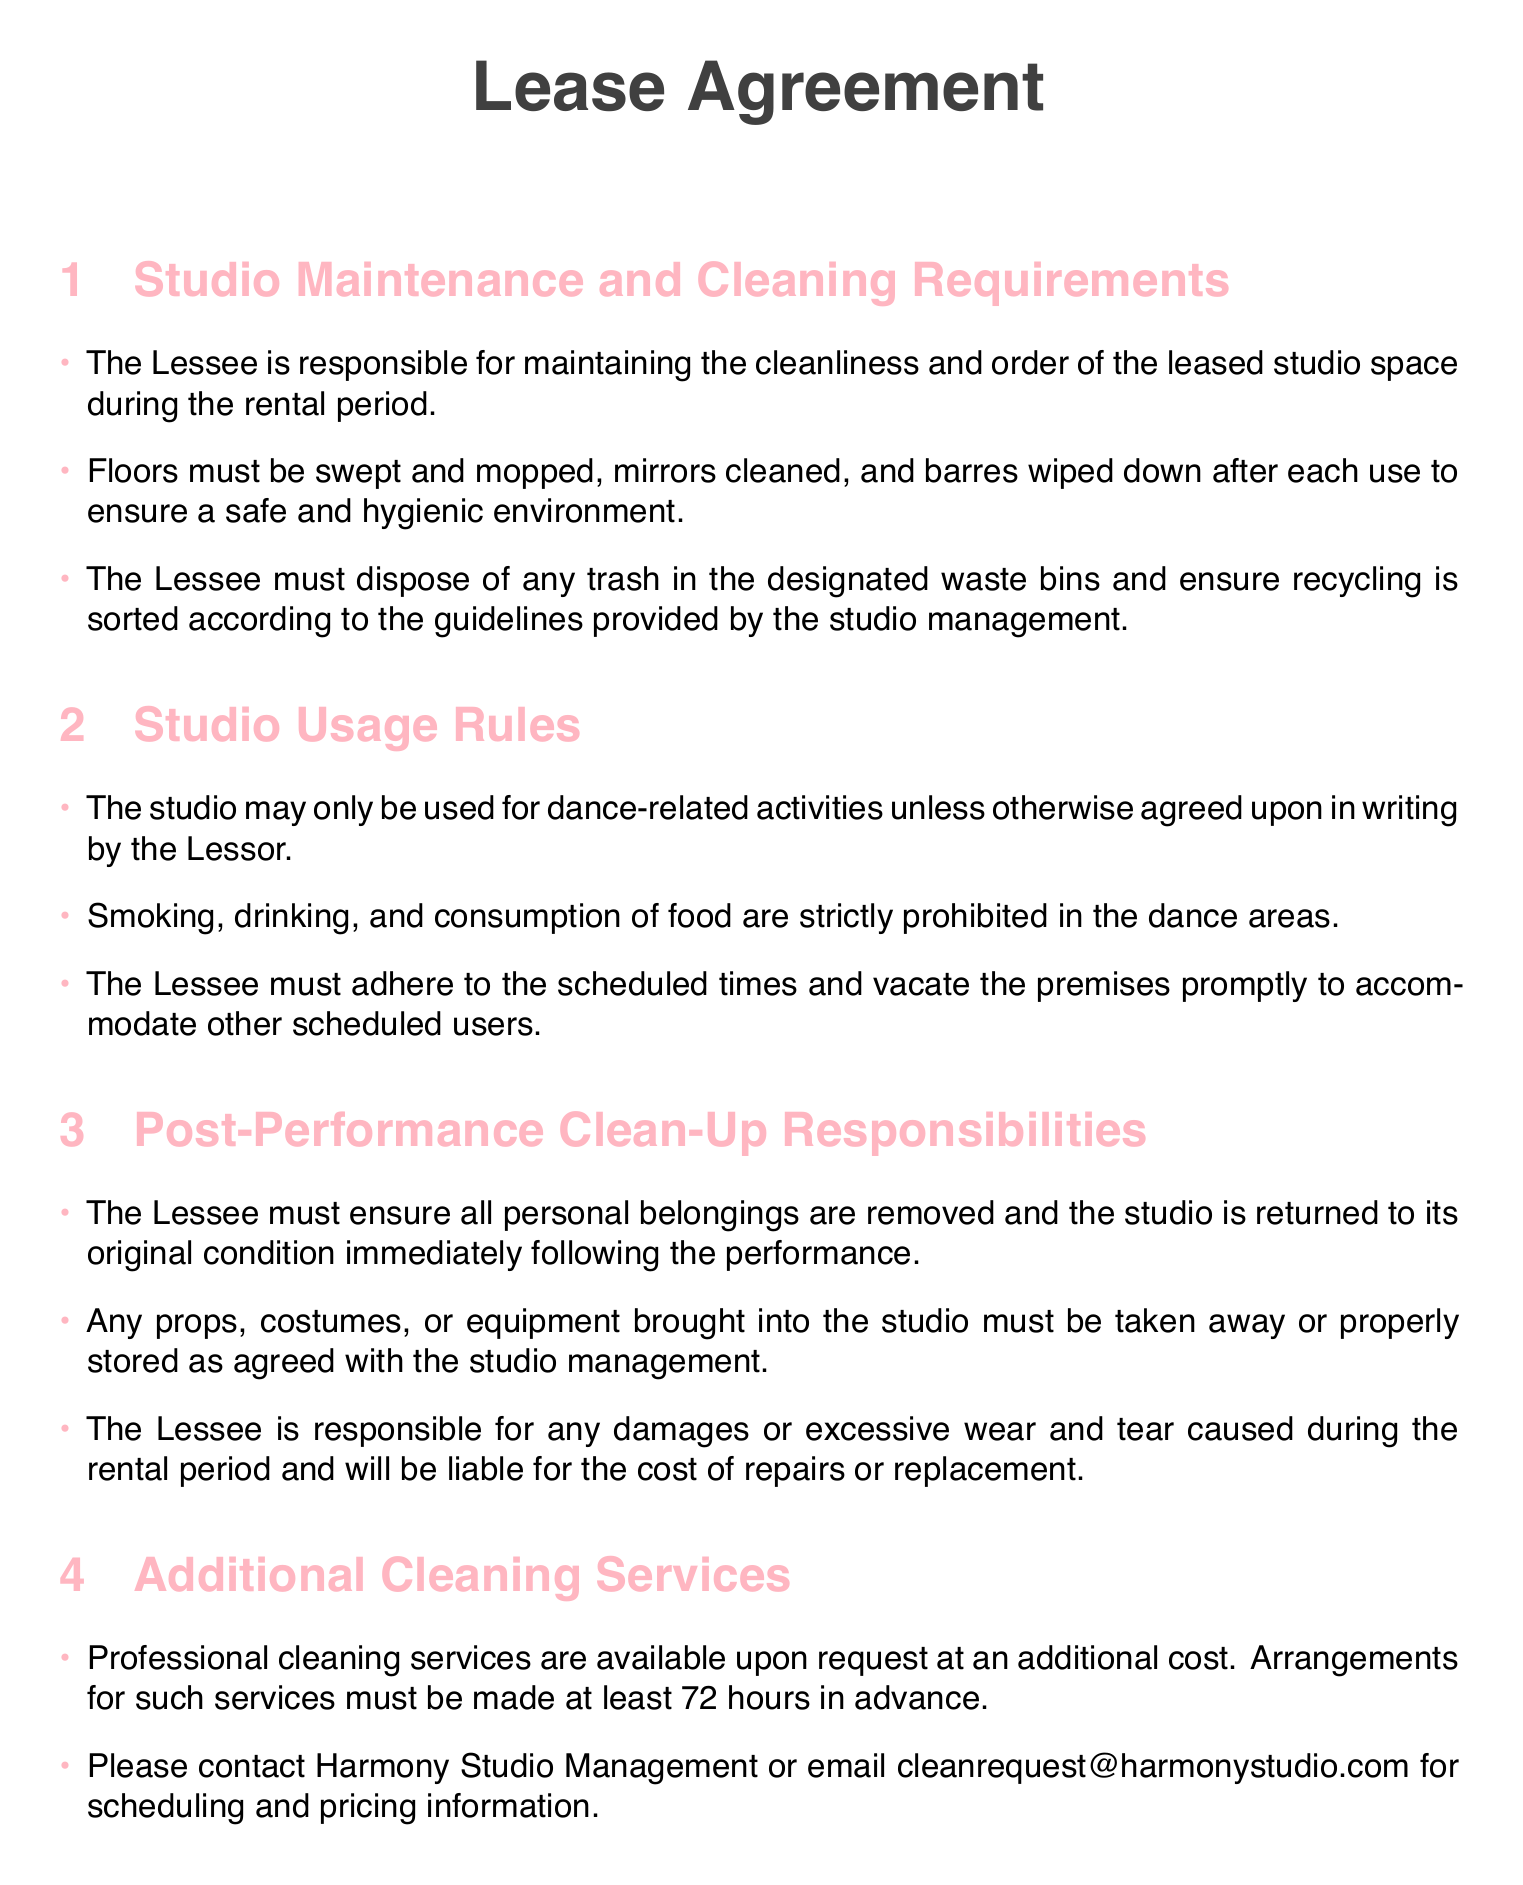what is the responsibility of the Lessee regarding cleanliness? The Lessee is responsible for maintaining the cleanliness and order of the leased studio space during the rental period.
Answer: maintaining cleanliness what must be done to the floors after each use? The document states that floors must be swept and mopped after each use.
Answer: swept and mopped are food and drinks allowed in the dance areas? The studio usage rules explicitly state that smoking, drinking, and consumption of food are strictly prohibited in the dance areas.
Answer: prohibited what should the Lessee do with personal belongings after the performance? The Lessee must ensure all personal belongings are removed and the studio is returned to its original condition immediately following the performance.
Answer: remove personal belongings how many hours in advance must cleaning services be scheduled? The document mentions that arrangements for cleaning services must be made at least 72 hours in advance.
Answer: 72 hours who is responsible for any damages caused during the rental period? The Lessee is responsible for any damages or excessive wear and tear caused during the rental period.
Answer: Lessee what is the email address for cleaning service requests? For cleaning service requests, the email address provided is cleanrequest@harmonystudio.com.
Answer: cleanrequest@harmonystudio.com is smoking allowed in the leased studio space? Smoking is strictly prohibited in the dance areas as per the studio usage rules.
Answer: prohibited 